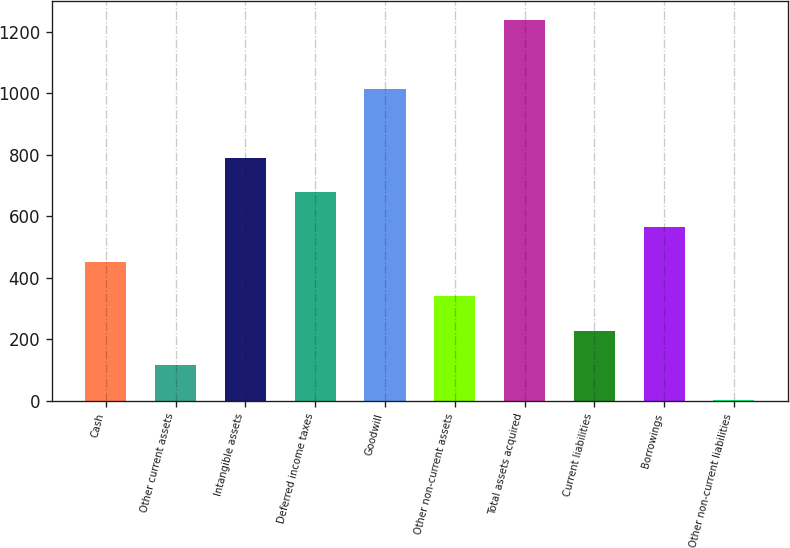Convert chart. <chart><loc_0><loc_0><loc_500><loc_500><bar_chart><fcel>Cash<fcel>Other current assets<fcel>Intangible assets<fcel>Deferred income taxes<fcel>Goodwill<fcel>Other non-current assets<fcel>Total assets acquired<fcel>Current liabilities<fcel>Borrowings<fcel>Other non-current liabilities<nl><fcel>452.2<fcel>115.3<fcel>789.1<fcel>676.8<fcel>1013.7<fcel>339.9<fcel>1238.3<fcel>227.6<fcel>564.5<fcel>3<nl></chart> 